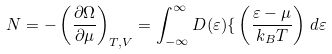<formula> <loc_0><loc_0><loc_500><loc_500>N = - \left ( { \frac { \partial \Omega } { \partial \mu } } \right ) _ { T , V } = \int _ { - \infty } ^ { \infty } D ( \varepsilon ) { \mathcal { f } } \left ( { \frac { \varepsilon - \mu } { k _ { B } T } } \right ) \, d \varepsilon</formula> 